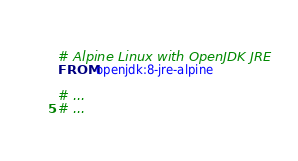Convert code to text. <code><loc_0><loc_0><loc_500><loc_500><_Dockerfile_># Alpine Linux with OpenJDK JRE
FROM openjdk:8-jre-alpine

# ...
# ...</code> 